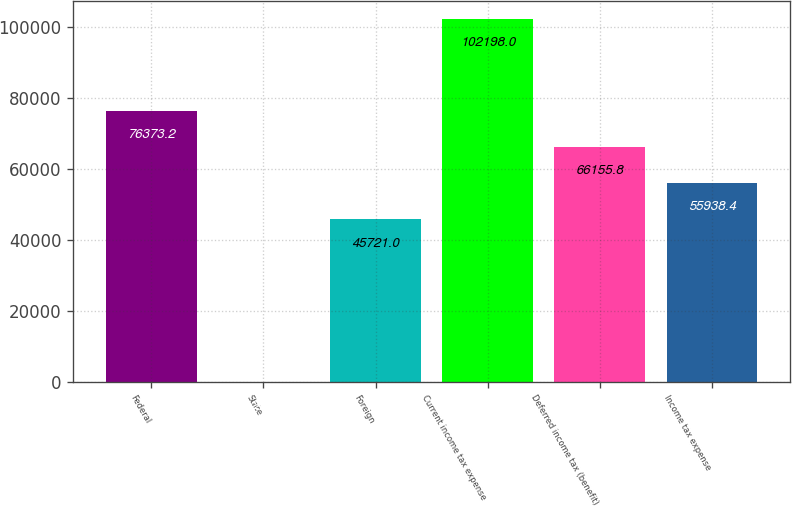Convert chart. <chart><loc_0><loc_0><loc_500><loc_500><bar_chart><fcel>Federal<fcel>State<fcel>Foreign<fcel>Current income tax expense<fcel>Deferred income tax (benefit)<fcel>Income tax expense<nl><fcel>76373.2<fcel>24<fcel>45721<fcel>102198<fcel>66155.8<fcel>55938.4<nl></chart> 